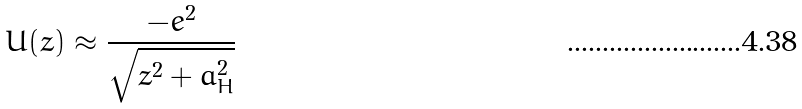<formula> <loc_0><loc_0><loc_500><loc_500>U ( z ) \approx \frac { - e ^ { 2 } } { \sqrt { z ^ { 2 } + a _ { H } ^ { 2 } } }</formula> 